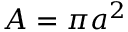<formula> <loc_0><loc_0><loc_500><loc_500>A = \pi a ^ { 2 }</formula> 